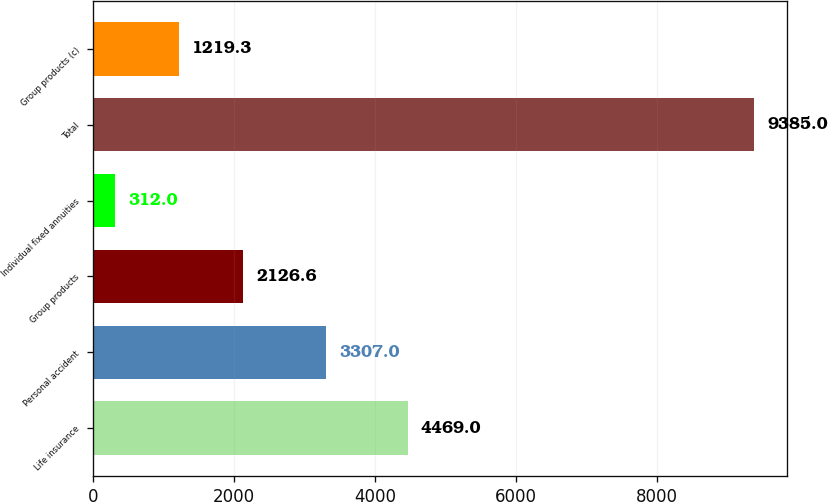Convert chart to OTSL. <chart><loc_0><loc_0><loc_500><loc_500><bar_chart><fcel>Life insurance<fcel>Personal accident<fcel>Group products<fcel>Individual fixed annuities<fcel>Total<fcel>Group products (c)<nl><fcel>4469<fcel>3307<fcel>2126.6<fcel>312<fcel>9385<fcel>1219.3<nl></chart> 